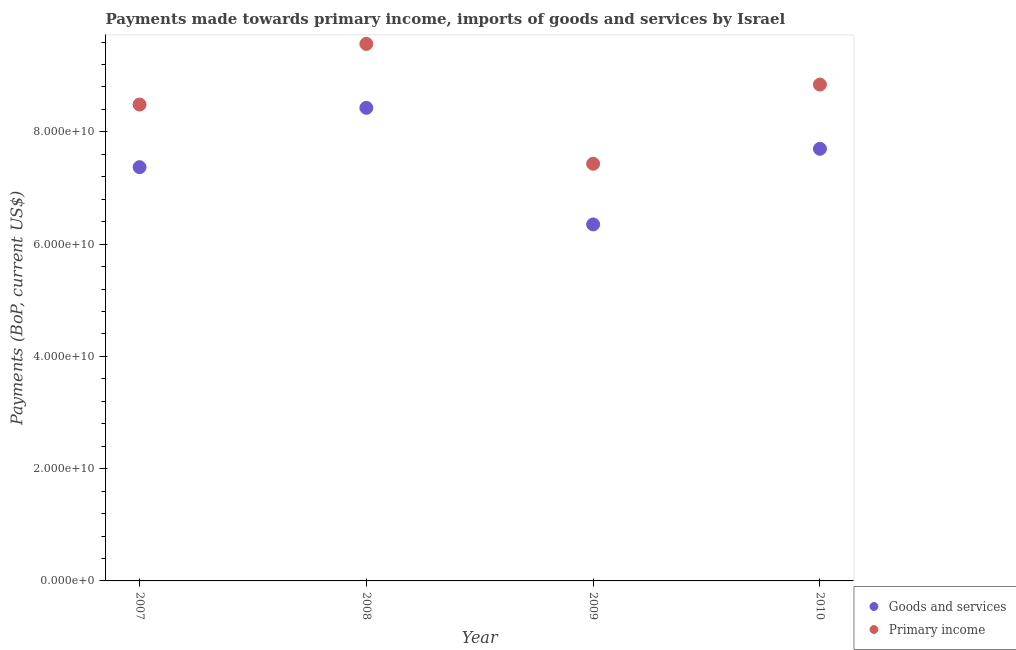What is the payments made towards primary income in 2007?
Provide a short and direct response. 8.49e+1. Across all years, what is the maximum payments made towards primary income?
Your answer should be very brief. 9.57e+1. Across all years, what is the minimum payments made towards goods and services?
Offer a very short reply. 6.35e+1. In which year was the payments made towards primary income minimum?
Ensure brevity in your answer.  2009. What is the total payments made towards goods and services in the graph?
Give a very brief answer. 2.98e+11. What is the difference between the payments made towards goods and services in 2008 and that in 2010?
Your response must be concise. 7.30e+09. What is the difference between the payments made towards primary income in 2008 and the payments made towards goods and services in 2009?
Ensure brevity in your answer.  3.22e+1. What is the average payments made towards goods and services per year?
Your answer should be very brief. 7.46e+1. In the year 2007, what is the difference between the payments made towards goods and services and payments made towards primary income?
Provide a short and direct response. -1.12e+1. What is the ratio of the payments made towards goods and services in 2008 to that in 2010?
Make the answer very short. 1.09. What is the difference between the highest and the second highest payments made towards primary income?
Your response must be concise. 7.24e+09. What is the difference between the highest and the lowest payments made towards goods and services?
Keep it short and to the point. 2.08e+1. In how many years, is the payments made towards goods and services greater than the average payments made towards goods and services taken over all years?
Ensure brevity in your answer.  2. Is the sum of the payments made towards goods and services in 2009 and 2010 greater than the maximum payments made towards primary income across all years?
Give a very brief answer. Yes. Does the payments made towards goods and services monotonically increase over the years?
Provide a short and direct response. No. Is the payments made towards primary income strictly greater than the payments made towards goods and services over the years?
Ensure brevity in your answer.  Yes. How many dotlines are there?
Keep it short and to the point. 2. How many years are there in the graph?
Provide a short and direct response. 4. Are the values on the major ticks of Y-axis written in scientific E-notation?
Ensure brevity in your answer.  Yes. Does the graph contain any zero values?
Provide a succinct answer. No. Does the graph contain grids?
Your answer should be very brief. No. How are the legend labels stacked?
Make the answer very short. Vertical. What is the title of the graph?
Your response must be concise. Payments made towards primary income, imports of goods and services by Israel. What is the label or title of the X-axis?
Give a very brief answer. Year. What is the label or title of the Y-axis?
Your response must be concise. Payments (BoP, current US$). What is the Payments (BoP, current US$) of Goods and services in 2007?
Provide a succinct answer. 7.37e+1. What is the Payments (BoP, current US$) of Primary income in 2007?
Give a very brief answer. 8.49e+1. What is the Payments (BoP, current US$) in Goods and services in 2008?
Give a very brief answer. 8.43e+1. What is the Payments (BoP, current US$) of Primary income in 2008?
Your answer should be compact. 9.57e+1. What is the Payments (BoP, current US$) of Goods and services in 2009?
Your answer should be compact. 6.35e+1. What is the Payments (BoP, current US$) of Primary income in 2009?
Give a very brief answer. 7.43e+1. What is the Payments (BoP, current US$) of Goods and services in 2010?
Your answer should be compact. 7.70e+1. What is the Payments (BoP, current US$) in Primary income in 2010?
Your answer should be very brief. 8.84e+1. Across all years, what is the maximum Payments (BoP, current US$) of Goods and services?
Offer a very short reply. 8.43e+1. Across all years, what is the maximum Payments (BoP, current US$) of Primary income?
Give a very brief answer. 9.57e+1. Across all years, what is the minimum Payments (BoP, current US$) in Goods and services?
Provide a short and direct response. 6.35e+1. Across all years, what is the minimum Payments (BoP, current US$) in Primary income?
Your response must be concise. 7.43e+1. What is the total Payments (BoP, current US$) of Goods and services in the graph?
Provide a succinct answer. 2.98e+11. What is the total Payments (BoP, current US$) in Primary income in the graph?
Offer a very short reply. 3.43e+11. What is the difference between the Payments (BoP, current US$) of Goods and services in 2007 and that in 2008?
Offer a terse response. -1.06e+1. What is the difference between the Payments (BoP, current US$) of Primary income in 2007 and that in 2008?
Keep it short and to the point. -1.08e+1. What is the difference between the Payments (BoP, current US$) of Goods and services in 2007 and that in 2009?
Your answer should be compact. 1.02e+1. What is the difference between the Payments (BoP, current US$) of Primary income in 2007 and that in 2009?
Offer a very short reply. 1.05e+1. What is the difference between the Payments (BoP, current US$) in Goods and services in 2007 and that in 2010?
Make the answer very short. -3.27e+09. What is the difference between the Payments (BoP, current US$) in Primary income in 2007 and that in 2010?
Give a very brief answer. -3.56e+09. What is the difference between the Payments (BoP, current US$) in Goods and services in 2008 and that in 2009?
Make the answer very short. 2.08e+1. What is the difference between the Payments (BoP, current US$) in Primary income in 2008 and that in 2009?
Your answer should be compact. 2.14e+1. What is the difference between the Payments (BoP, current US$) in Goods and services in 2008 and that in 2010?
Provide a short and direct response. 7.30e+09. What is the difference between the Payments (BoP, current US$) of Primary income in 2008 and that in 2010?
Give a very brief answer. 7.24e+09. What is the difference between the Payments (BoP, current US$) of Goods and services in 2009 and that in 2010?
Offer a very short reply. -1.35e+1. What is the difference between the Payments (BoP, current US$) in Primary income in 2009 and that in 2010?
Ensure brevity in your answer.  -1.41e+1. What is the difference between the Payments (BoP, current US$) in Goods and services in 2007 and the Payments (BoP, current US$) in Primary income in 2008?
Provide a succinct answer. -2.20e+1. What is the difference between the Payments (BoP, current US$) in Goods and services in 2007 and the Payments (BoP, current US$) in Primary income in 2009?
Offer a very short reply. -6.09e+08. What is the difference between the Payments (BoP, current US$) in Goods and services in 2007 and the Payments (BoP, current US$) in Primary income in 2010?
Give a very brief answer. -1.47e+1. What is the difference between the Payments (BoP, current US$) in Goods and services in 2008 and the Payments (BoP, current US$) in Primary income in 2009?
Offer a terse response. 9.96e+09. What is the difference between the Payments (BoP, current US$) in Goods and services in 2008 and the Payments (BoP, current US$) in Primary income in 2010?
Your answer should be very brief. -4.15e+09. What is the difference between the Payments (BoP, current US$) in Goods and services in 2009 and the Payments (BoP, current US$) in Primary income in 2010?
Keep it short and to the point. -2.49e+1. What is the average Payments (BoP, current US$) of Goods and services per year?
Offer a terse response. 7.46e+1. What is the average Payments (BoP, current US$) in Primary income per year?
Offer a terse response. 8.58e+1. In the year 2007, what is the difference between the Payments (BoP, current US$) in Goods and services and Payments (BoP, current US$) in Primary income?
Your response must be concise. -1.12e+1. In the year 2008, what is the difference between the Payments (BoP, current US$) of Goods and services and Payments (BoP, current US$) of Primary income?
Provide a short and direct response. -1.14e+1. In the year 2009, what is the difference between the Payments (BoP, current US$) in Goods and services and Payments (BoP, current US$) in Primary income?
Give a very brief answer. -1.08e+1. In the year 2010, what is the difference between the Payments (BoP, current US$) of Goods and services and Payments (BoP, current US$) of Primary income?
Your answer should be compact. -1.14e+1. What is the ratio of the Payments (BoP, current US$) of Goods and services in 2007 to that in 2008?
Your answer should be compact. 0.87. What is the ratio of the Payments (BoP, current US$) of Primary income in 2007 to that in 2008?
Provide a short and direct response. 0.89. What is the ratio of the Payments (BoP, current US$) of Goods and services in 2007 to that in 2009?
Offer a very short reply. 1.16. What is the ratio of the Payments (BoP, current US$) in Primary income in 2007 to that in 2009?
Your answer should be compact. 1.14. What is the ratio of the Payments (BoP, current US$) in Goods and services in 2007 to that in 2010?
Your answer should be very brief. 0.96. What is the ratio of the Payments (BoP, current US$) of Primary income in 2007 to that in 2010?
Give a very brief answer. 0.96. What is the ratio of the Payments (BoP, current US$) of Goods and services in 2008 to that in 2009?
Make the answer very short. 1.33. What is the ratio of the Payments (BoP, current US$) in Primary income in 2008 to that in 2009?
Keep it short and to the point. 1.29. What is the ratio of the Payments (BoP, current US$) in Goods and services in 2008 to that in 2010?
Your response must be concise. 1.09. What is the ratio of the Payments (BoP, current US$) of Primary income in 2008 to that in 2010?
Offer a terse response. 1.08. What is the ratio of the Payments (BoP, current US$) of Goods and services in 2009 to that in 2010?
Make the answer very short. 0.82. What is the ratio of the Payments (BoP, current US$) in Primary income in 2009 to that in 2010?
Offer a terse response. 0.84. What is the difference between the highest and the second highest Payments (BoP, current US$) of Goods and services?
Provide a succinct answer. 7.30e+09. What is the difference between the highest and the second highest Payments (BoP, current US$) in Primary income?
Provide a succinct answer. 7.24e+09. What is the difference between the highest and the lowest Payments (BoP, current US$) in Goods and services?
Your answer should be very brief. 2.08e+1. What is the difference between the highest and the lowest Payments (BoP, current US$) in Primary income?
Keep it short and to the point. 2.14e+1. 